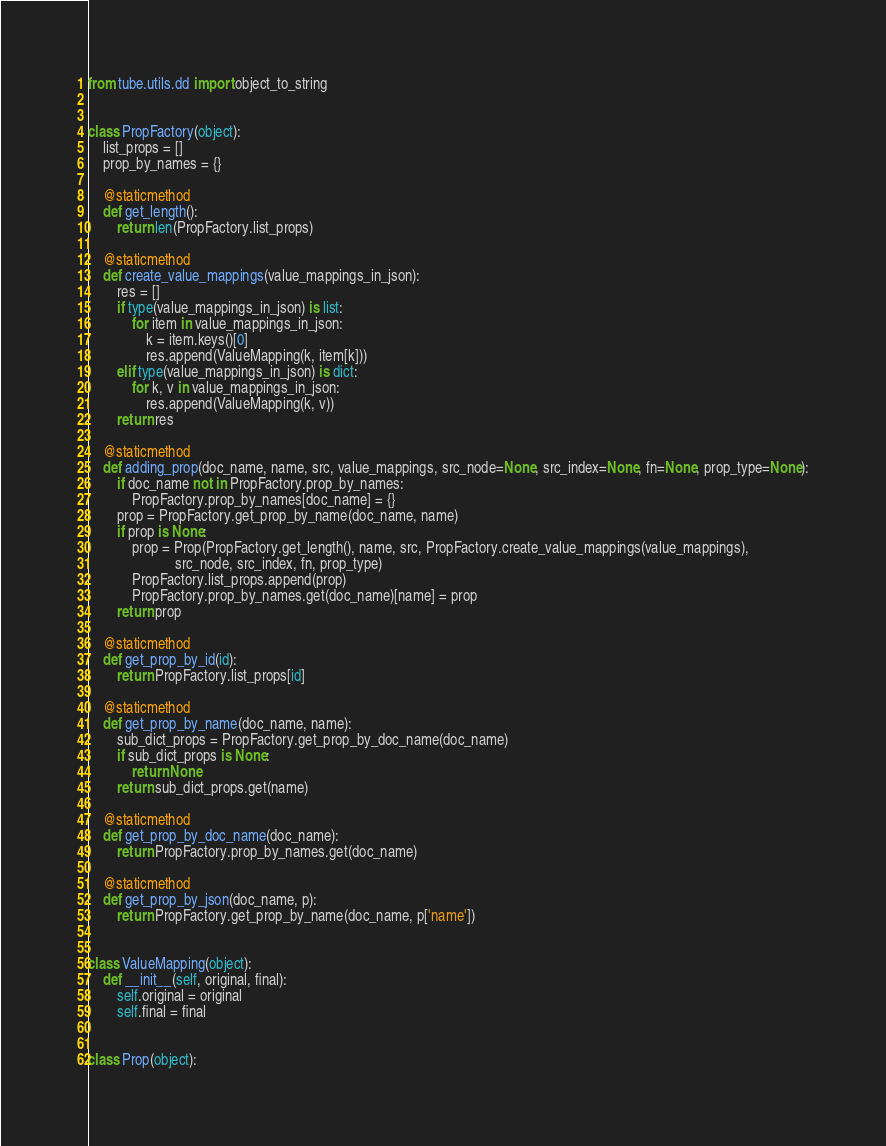<code> <loc_0><loc_0><loc_500><loc_500><_Python_>from tube.utils.dd import object_to_string


class PropFactory(object):
    list_props = []
    prop_by_names = {}

    @staticmethod
    def get_length():
        return len(PropFactory.list_props)

    @staticmethod
    def create_value_mappings(value_mappings_in_json):
        res = []
        if type(value_mappings_in_json) is list:
            for item in value_mappings_in_json:
                k = item.keys()[0]
                res.append(ValueMapping(k, item[k]))
        elif type(value_mappings_in_json) is dict:
            for k, v in value_mappings_in_json:
                res.append(ValueMapping(k, v))
        return res

    @staticmethod
    def adding_prop(doc_name, name, src, value_mappings, src_node=None, src_index=None, fn=None, prop_type=None):
        if doc_name not in PropFactory.prop_by_names:
            PropFactory.prop_by_names[doc_name] = {}
        prop = PropFactory.get_prop_by_name(doc_name, name)
        if prop is None:
            prop = Prop(PropFactory.get_length(), name, src, PropFactory.create_value_mappings(value_mappings),
                        src_node, src_index, fn, prop_type)
            PropFactory.list_props.append(prop)
            PropFactory.prop_by_names.get(doc_name)[name] = prop
        return prop

    @staticmethod
    def get_prop_by_id(id):
        return PropFactory.list_props[id]

    @staticmethod
    def get_prop_by_name(doc_name, name):
        sub_dict_props = PropFactory.get_prop_by_doc_name(doc_name)
        if sub_dict_props is None:
            return None
        return sub_dict_props.get(name)

    @staticmethod
    def get_prop_by_doc_name(doc_name):
        return PropFactory.prop_by_names.get(doc_name)

    @staticmethod
    def get_prop_by_json(doc_name, p):
        return PropFactory.get_prop_by_name(doc_name, p['name'])


class ValueMapping(object):
    def __init__(self, original, final):
        self.original = original
        self.final = final


class Prop(object):</code> 